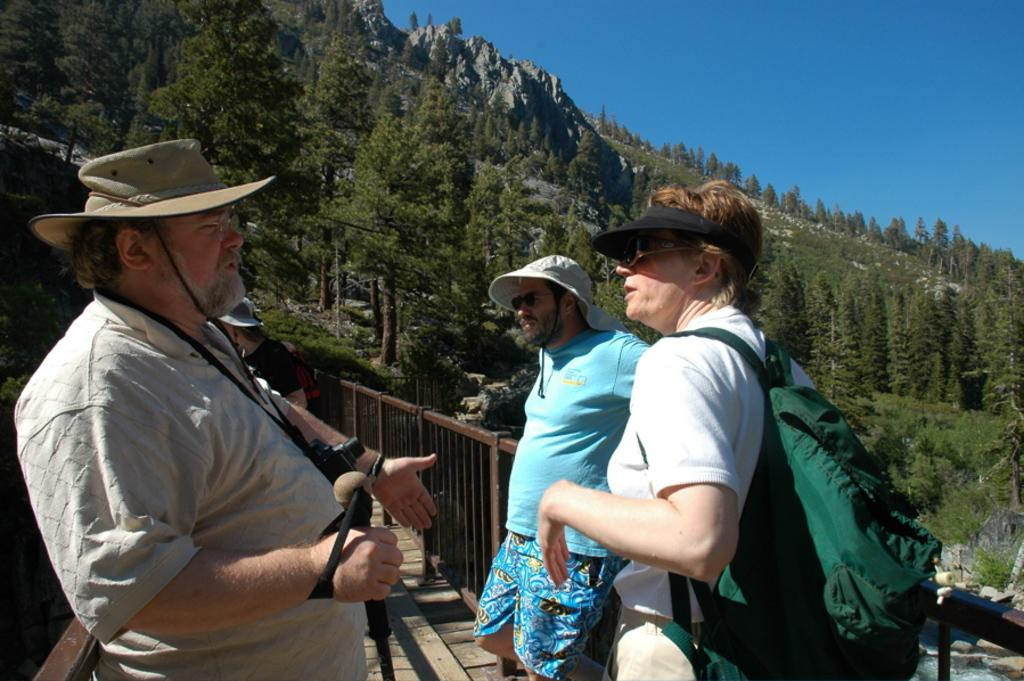How many people are in the foreground of the image? There are three persons standing in the foreground of the image. What can be seen in the background of the image? There are trees and a mountain visible in the background of the image. What type of knowledge can be gained from the cemetery in the image? There is no cemetery present in the image, so no knowledge can be gained from it. How many rabbits can be seen hopping around in the image? There are no rabbits present in the image. 